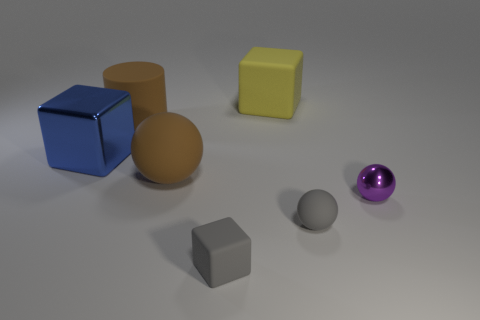The matte thing that is the same color as the large sphere is what size?
Provide a short and direct response. Large. Do the tiny matte sphere and the tiny block have the same color?
Your response must be concise. Yes. There is a cylinder that is the same color as the large matte sphere; what material is it?
Your response must be concise. Rubber. Are there any other things of the same color as the big rubber cylinder?
Offer a very short reply. Yes. The big matte object that is the same color as the large cylinder is what shape?
Keep it short and to the point. Sphere. Is the color of the matte sphere left of the yellow matte object the same as the rubber object to the left of the big brown rubber ball?
Keep it short and to the point. Yes. Do the large thing on the right side of the brown sphere and the sphere on the right side of the gray sphere have the same material?
Your answer should be compact. No. There is a tiny gray object to the right of the large block that is on the right side of the blue block; what is it made of?
Keep it short and to the point. Rubber. Is there a object that has the same color as the large cylinder?
Make the answer very short. Yes. There is a metal thing that is to the left of the gray object on the right side of the big yellow thing; what color is it?
Offer a terse response. Blue. 